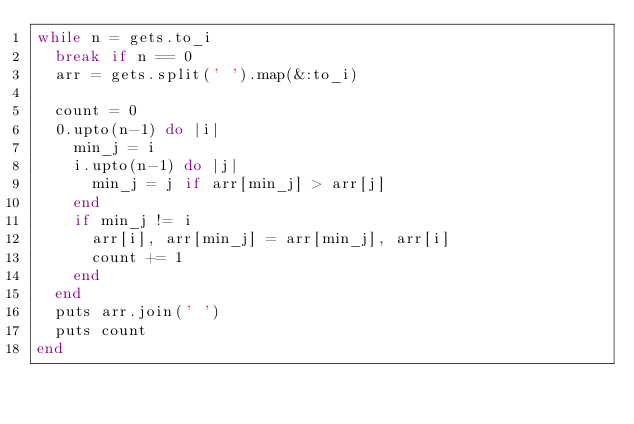<code> <loc_0><loc_0><loc_500><loc_500><_Ruby_>while n = gets.to_i
  break if n == 0
  arr = gets.split(' ').map(&:to_i)

  count = 0
  0.upto(n-1) do |i|
    min_j = i
    i.upto(n-1) do |j|
      min_j = j if arr[min_j] > arr[j]
    end
    if min_j != i
      arr[i], arr[min_j] = arr[min_j], arr[i]
      count += 1
    end
  end
  puts arr.join(' ')
  puts count
end</code> 